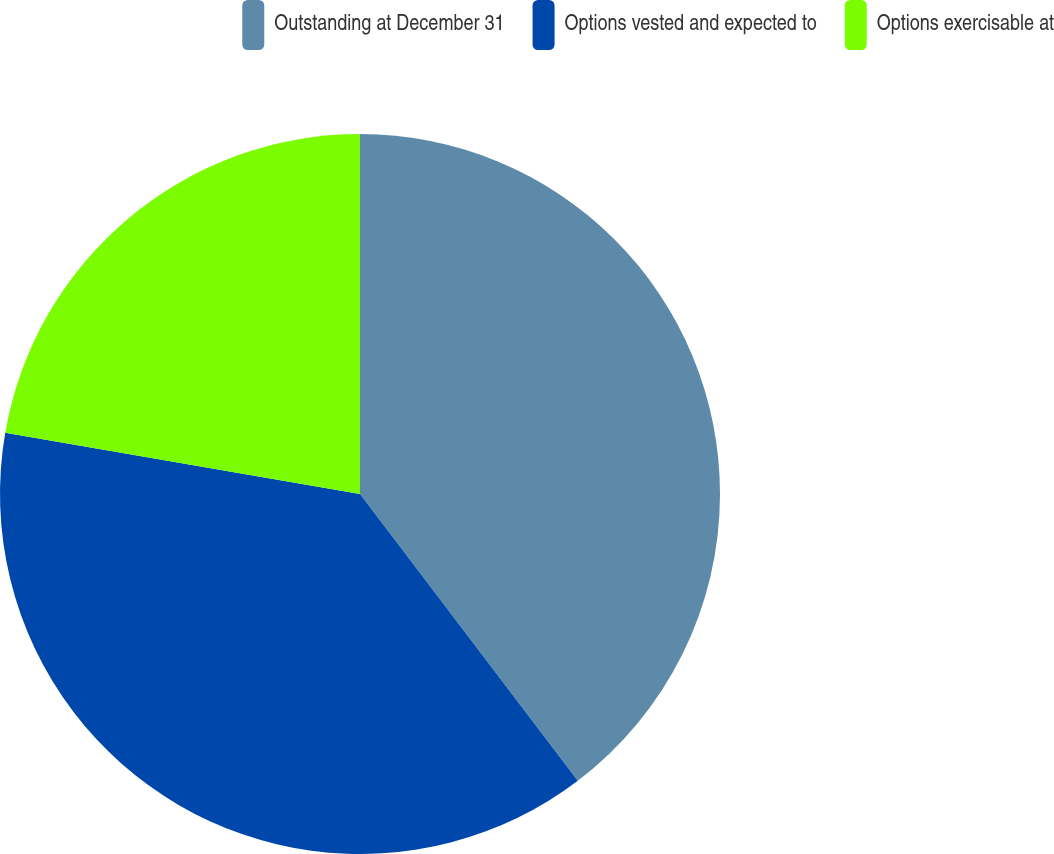Convert chart to OTSL. <chart><loc_0><loc_0><loc_500><loc_500><pie_chart><fcel>Outstanding at December 31<fcel>Options vested and expected to<fcel>Options exercisable at<nl><fcel>39.66%<fcel>38.06%<fcel>22.28%<nl></chart> 